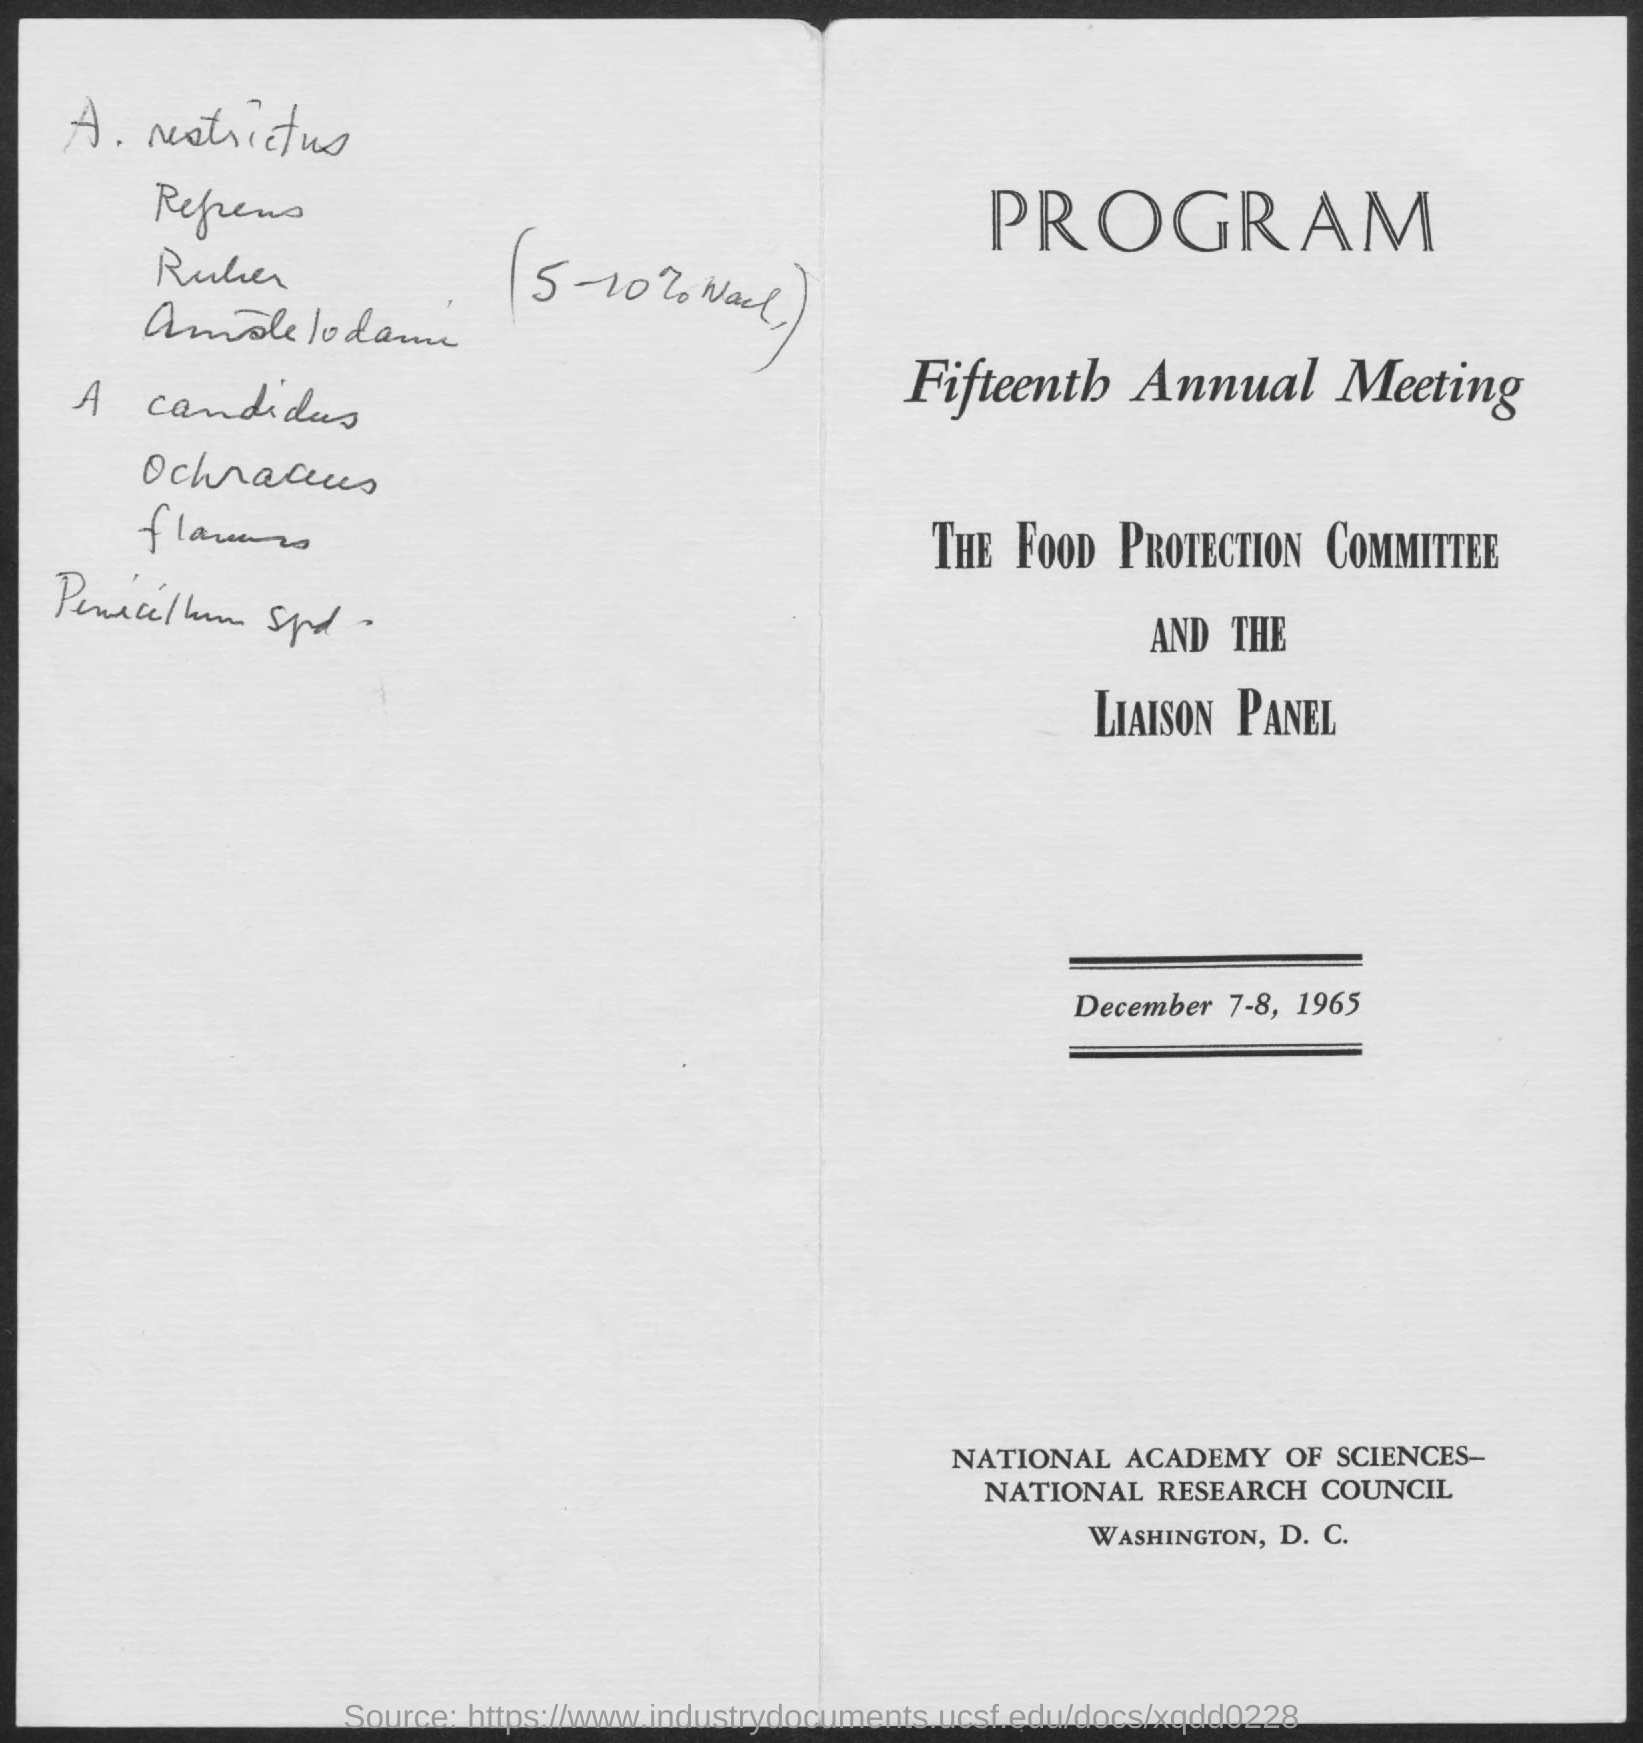Identify some key points in this picture. The document contains the date range December 7-8, 1965. 